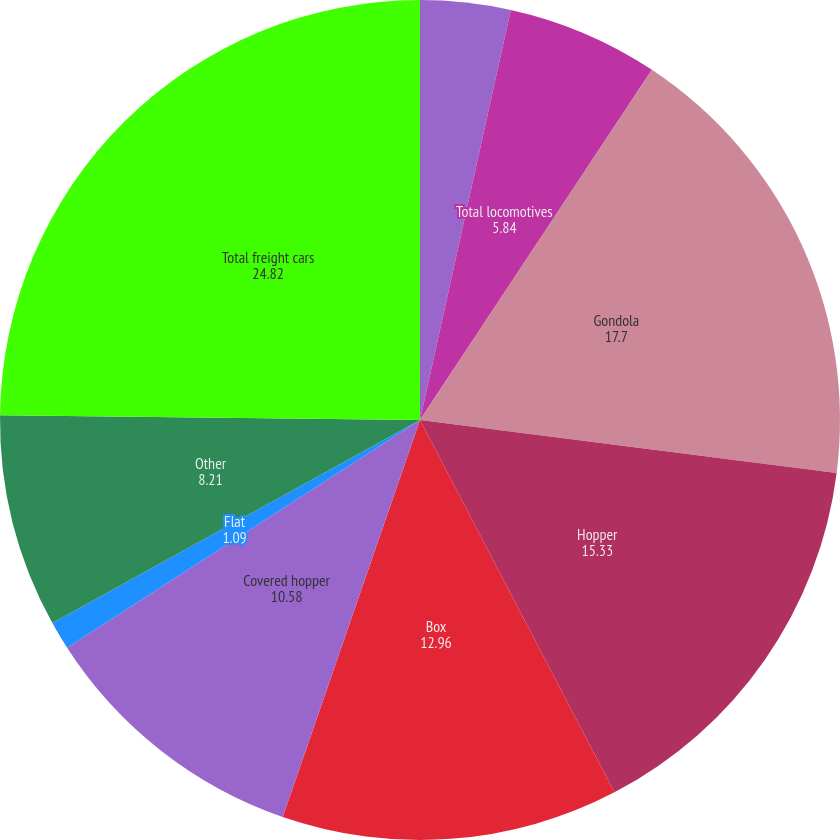<chart> <loc_0><loc_0><loc_500><loc_500><pie_chart><fcel>Multiple purpose<fcel>Total locomotives<fcel>Gondola<fcel>Hopper<fcel>Box<fcel>Covered hopper<fcel>Flat<fcel>Other<fcel>Total freight cars<nl><fcel>3.47%<fcel>5.84%<fcel>17.7%<fcel>15.33%<fcel>12.96%<fcel>10.58%<fcel>1.09%<fcel>8.21%<fcel>24.82%<nl></chart> 